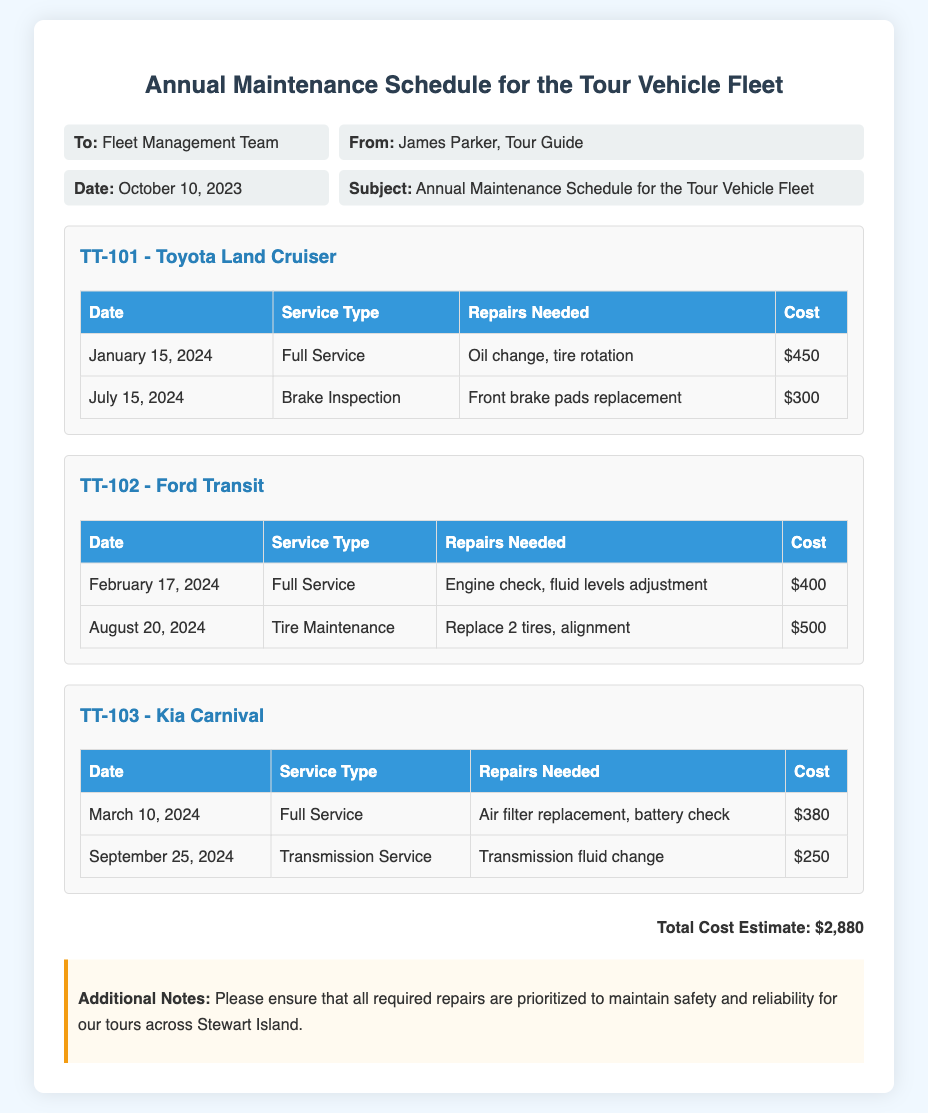what is the total cost estimate? The total cost estimate is provided as the sum of all service costs for the vehicles in the memo.
Answer: $2,880 who is the author of the memo? The author is identified at the beginning of the memo as James Parker, Tour Guide.
Answer: James Parker when is the first service date for the Toyota Land Cruiser? The first service date is listed in the table specific to the Toyota Land Cruiser vehicle.
Answer: January 15, 2024 what repairs are needed for the Ford Transit on February 17, 2024? The repairs needed for the Ford Transit are detailed in the service type and repairs needed columns of the table.
Answer: Engine check, fluid levels adjustment how many vehicles are listed in the maintenance schedule? The number of vehicles can be counted based on how many vehicle sections are in the memo.
Answer: 3 what is the main purpose of this memo? The main purpose of the memo is articulated in the subject line to communicate the annual maintenance schedule for the vehicle fleet.
Answer: Annual Maintenance Schedule for the Tour Vehicle Fleet which vehicle requires transmission service in September? The vehicle requiring transmission service is specified in the respective service schedule for that vehicle.
Answer: Kia Carnival what is the service type scheduled for July 15, 2024, for the Toyota Land Cruiser? The service type is clearly stated within the table related to the Toyota Land Cruiser.
Answer: Brake Inspection 